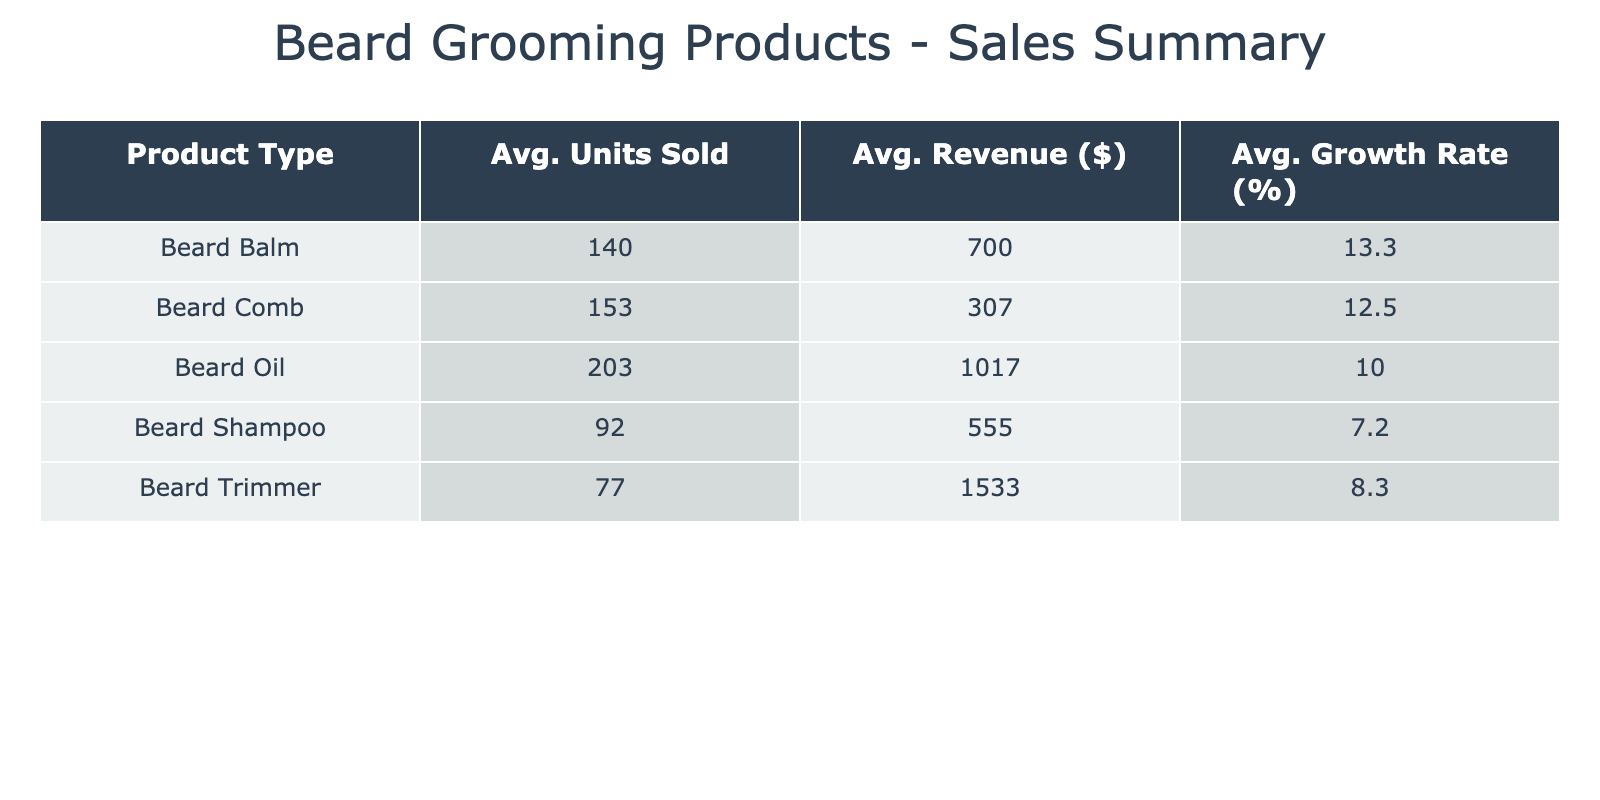What is the average revenue from Beard Balm? The average revenue for Beard Balm can be calculated by finding the average of the revenue values for this product over the months. The revenue values are 500, 600, 750, 700, 800, and 850, which sum up to 3900. There are 6 months of data, so the average revenue is 3900 divided by 6, yielding approximately 650.
Answer: 650 What product had the highest average units sold? To answer this, we need to examine the average units sold for each product type. The averages are: Beard Oil (195), Beard Balm (136.67), Beard Shampoo (92.5), Beard Comb (145), and Beard Trimmer (75). The highest average is for Beard Oil with 195 units sold.
Answer: Beard Oil Is the average growth rate for Beard Oil greater than that for Beard Trimmer? The average growth rate for Beard Oil is calculated from the values 5, 20, 11, 5, 10, and 9, which gives 10. The average growth rate for Beard Trimmer is derived from 2, 16, 7, 7, 13, and 5, which results in approximately 8.83. Since 10 is greater than 8.83, the answer is yes.
Answer: Yes What is the total revenue generated from Beard Comb sales over the six months? To find the total revenue from Beard Comb sales, we add the revenue for each month: 240, 280, 320, 300, 340, and 360. Summing these values gives us 1840 in total revenue from Beard Comb.
Answer: 1840 What is the difference between the average units sold for Beard Balm and Beard Shampoo? The average units sold for Beard Balm is 136.67, while for Beard Shampoo it is 92.5. To find the difference, subtract the average of Beard Shampoo from that of Beard Balm: 136.67 - 92.5 = 44.17. Therefore, the difference is approximately 44.17 units.
Answer: 44.17 Did Beard Oil experience an increase in units sold every month from January to June? From the table, the units sold for Beard Oil are 150, 180, 200, 210, 230, and 250. Observing these values, we can see that they consistently increase each month, indicating yes, there was an increase every month.
Answer: Yes What is the average revenue for Beard Shampoo for the period? To find the average revenue for Beard Shampoo, we sum the revenues 480, 540, 510, 570, 600, and 630. This results in a total of 3300. Dividing this by the number of months (6) gives an average revenue of 550.
Answer: 550 Which product had the lowest average growth rate? The average growth rates for the products are: Beard Oil (10.00), Beard Balm (12.50), Beard Shampoo (10.00), Beard Comb (12.50), and Beard Trimmer (8.83). The lowest average growth rate is for Beard Trimmer at approximately 8.83%.
Answer: Beard Trimmer 